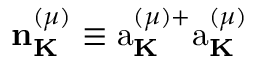Convert formula to latex. <formula><loc_0><loc_0><loc_500><loc_500>{ n } _ { K } ^ { ( \mu ) } \equiv a _ { K } ^ { ( \mu ) + } a _ { K } ^ { ( \mu ) }</formula> 